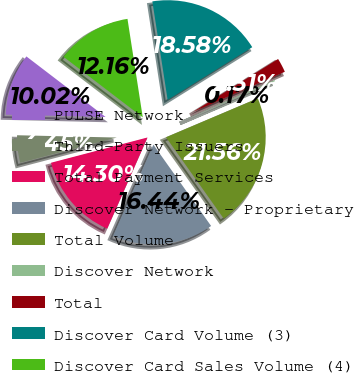Convert chart to OTSL. <chart><loc_0><loc_0><loc_500><loc_500><pie_chart><fcel>PULSE Network<fcel>Third-Party Issuers<fcel>Total Payment Services<fcel>Discover Network - Proprietary<fcel>Total Volume<fcel>Discover Network<fcel>Total<fcel>Discover Card Volume (3)<fcel>Discover Card Sales Volume (4)<nl><fcel>10.02%<fcel>4.45%<fcel>14.3%<fcel>16.44%<fcel>21.56%<fcel>0.17%<fcel>2.31%<fcel>18.58%<fcel>12.16%<nl></chart> 